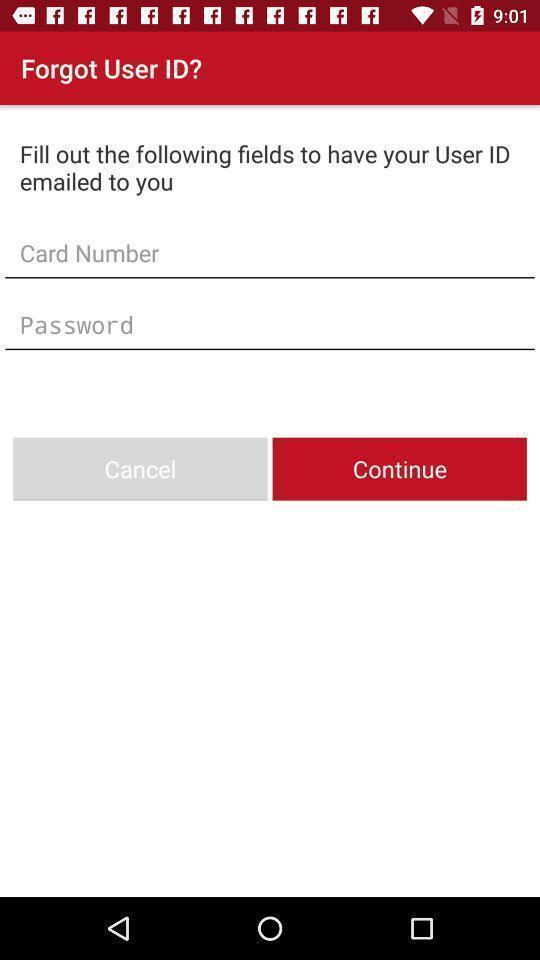Provide a textual representation of this image. Sign in page for user id. 